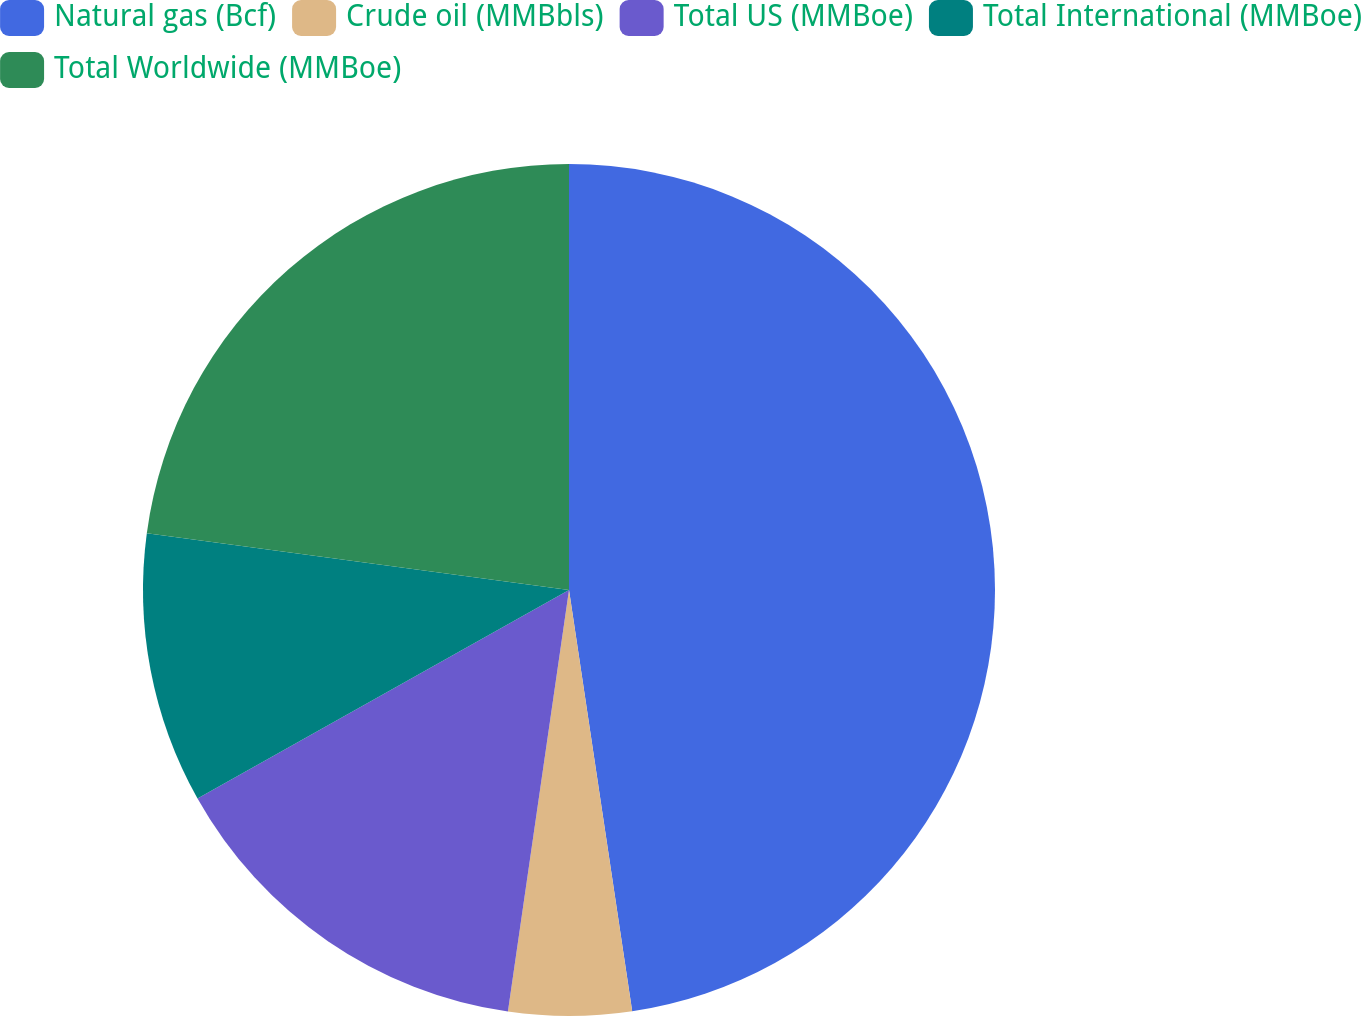<chart> <loc_0><loc_0><loc_500><loc_500><pie_chart><fcel>Natural gas (Bcf)<fcel>Crude oil (MMBbls)<fcel>Total US (MMBoe)<fcel>Total International (MMBoe)<fcel>Total Worldwide (MMBoe)<nl><fcel>47.63%<fcel>4.66%<fcel>14.57%<fcel>10.27%<fcel>22.87%<nl></chart> 